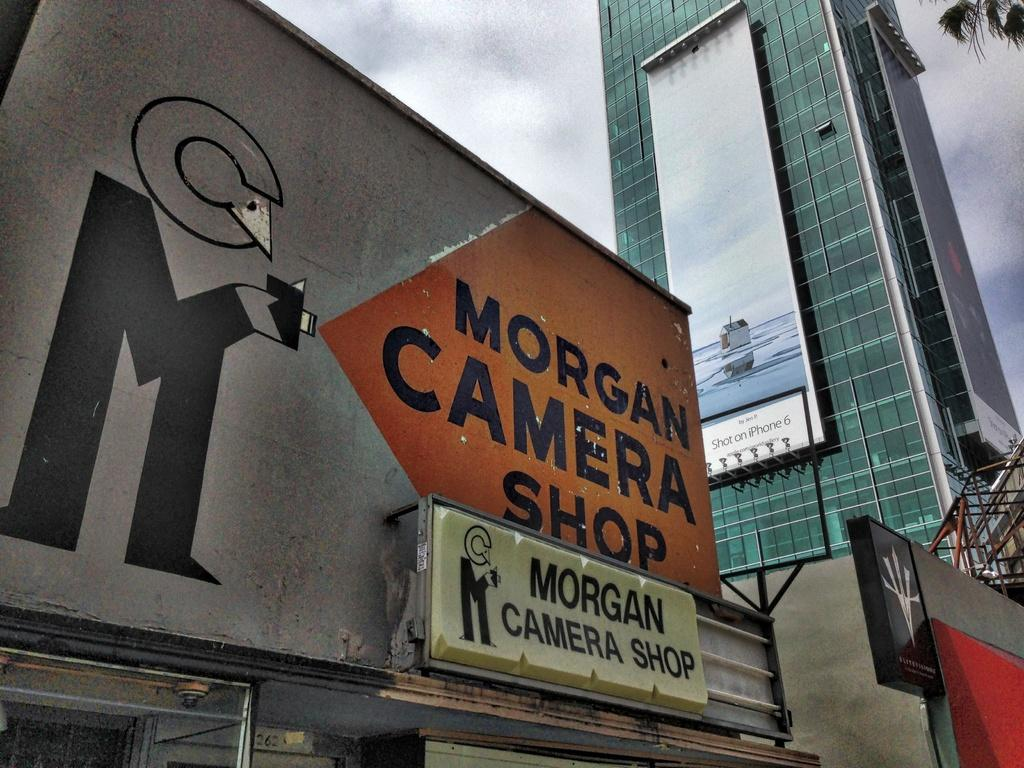What type of structures can be seen in the image? There are buildings in the image. What is the purpose of the screen in the image? The purpose of the screen is not specified in the image. Are there any architectural features visible in the image? Yes, there are stairs in the image. What is visible in the background of the image? The sky is visible in the image, and clouds are present in the sky. What type of game is being played on the screen in the image? There is no game being played on the screen in the image. Can you see a goose flying in the sky in the image? There is no goose present in the image. 